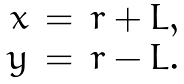Convert formula to latex. <formula><loc_0><loc_0><loc_500><loc_500>\begin{array} { r c l } x & = & r + L , \\ y & = & r - L . \end{array}</formula> 